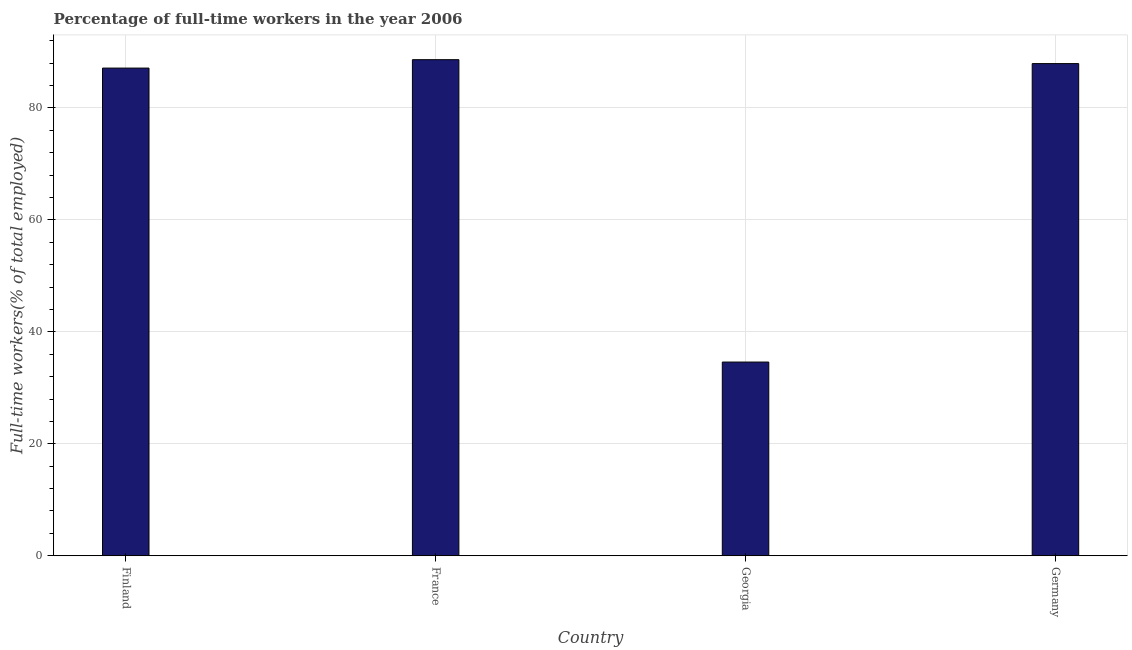Does the graph contain any zero values?
Your answer should be very brief. No. Does the graph contain grids?
Offer a very short reply. Yes. What is the title of the graph?
Ensure brevity in your answer.  Percentage of full-time workers in the year 2006. What is the label or title of the X-axis?
Make the answer very short. Country. What is the label or title of the Y-axis?
Your answer should be compact. Full-time workers(% of total employed). What is the percentage of full-time workers in Germany?
Offer a terse response. 87.9. Across all countries, what is the maximum percentage of full-time workers?
Provide a short and direct response. 88.6. Across all countries, what is the minimum percentage of full-time workers?
Your answer should be compact. 34.6. In which country was the percentage of full-time workers maximum?
Ensure brevity in your answer.  France. In which country was the percentage of full-time workers minimum?
Your answer should be compact. Georgia. What is the sum of the percentage of full-time workers?
Offer a very short reply. 298.2. What is the difference between the percentage of full-time workers in Georgia and Germany?
Provide a short and direct response. -53.3. What is the average percentage of full-time workers per country?
Your answer should be compact. 74.55. What is the median percentage of full-time workers?
Make the answer very short. 87.5. In how many countries, is the percentage of full-time workers greater than 24 %?
Ensure brevity in your answer.  4. What is the ratio of the percentage of full-time workers in Finland to that in France?
Your answer should be compact. 0.98. Is the percentage of full-time workers in Georgia less than that in Germany?
Offer a very short reply. Yes. Is the difference between the percentage of full-time workers in Finland and Georgia greater than the difference between any two countries?
Make the answer very short. No. What is the difference between the highest and the second highest percentage of full-time workers?
Make the answer very short. 0.7. Are all the bars in the graph horizontal?
Your response must be concise. No. How many countries are there in the graph?
Provide a succinct answer. 4. What is the Full-time workers(% of total employed) in Finland?
Ensure brevity in your answer.  87.1. What is the Full-time workers(% of total employed) of France?
Ensure brevity in your answer.  88.6. What is the Full-time workers(% of total employed) of Georgia?
Ensure brevity in your answer.  34.6. What is the Full-time workers(% of total employed) of Germany?
Offer a terse response. 87.9. What is the difference between the Full-time workers(% of total employed) in Finland and Georgia?
Keep it short and to the point. 52.5. What is the difference between the Full-time workers(% of total employed) in France and Germany?
Your answer should be compact. 0.7. What is the difference between the Full-time workers(% of total employed) in Georgia and Germany?
Ensure brevity in your answer.  -53.3. What is the ratio of the Full-time workers(% of total employed) in Finland to that in Georgia?
Your answer should be compact. 2.52. What is the ratio of the Full-time workers(% of total employed) in France to that in Georgia?
Keep it short and to the point. 2.56. What is the ratio of the Full-time workers(% of total employed) in France to that in Germany?
Your answer should be very brief. 1.01. What is the ratio of the Full-time workers(% of total employed) in Georgia to that in Germany?
Your answer should be very brief. 0.39. 